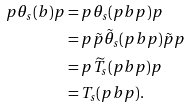Convert formula to latex. <formula><loc_0><loc_0><loc_500><loc_500>p \theta _ { s } ( b ) p & = p \theta _ { s } ( p b p ) p \\ & = p \tilde { p } \tilde { \theta } _ { s } ( p b p ) \tilde { p } p \\ & = p \widetilde { T } _ { s } ( p b p ) p \\ & = T _ { s } ( p b p ) .</formula> 